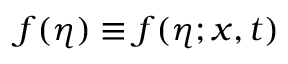Convert formula to latex. <formula><loc_0><loc_0><loc_500><loc_500>f ( \eta ) \equiv f ( \eta ; x , t )</formula> 